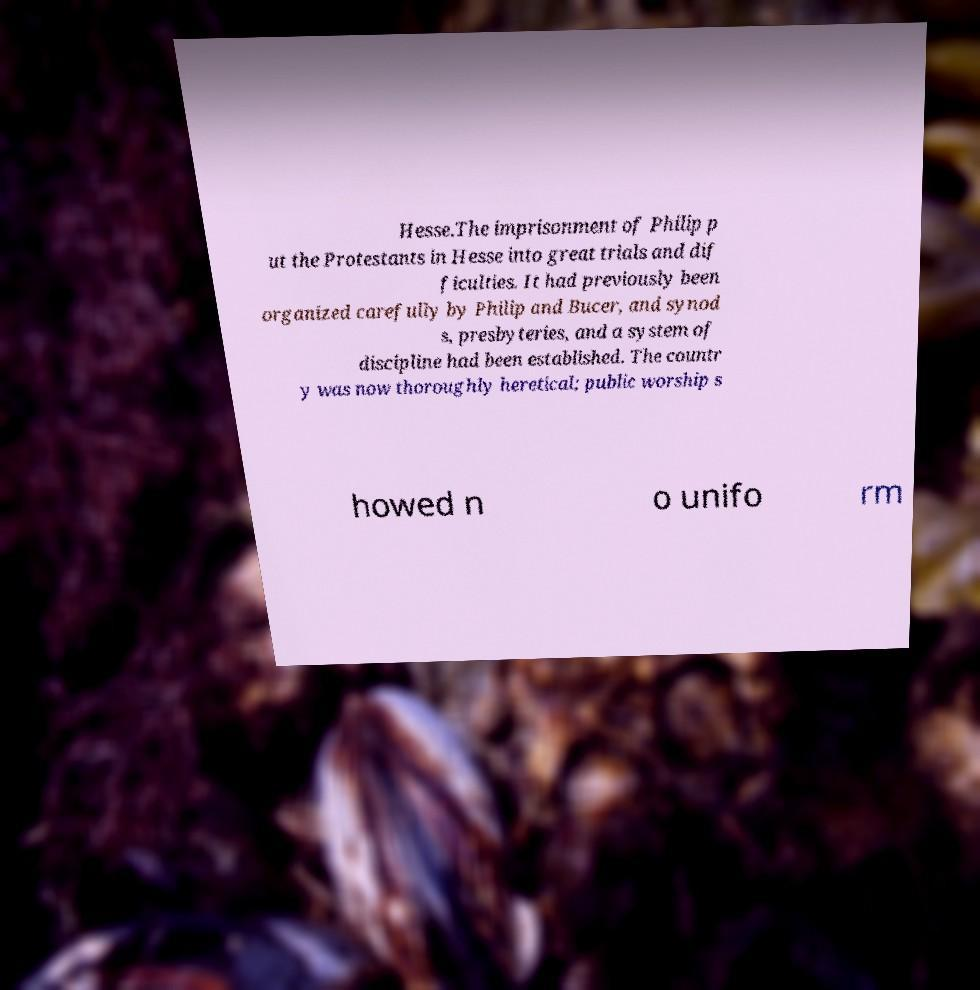There's text embedded in this image that I need extracted. Can you transcribe it verbatim? Hesse.The imprisonment of Philip p ut the Protestants in Hesse into great trials and dif ficulties. It had previously been organized carefully by Philip and Bucer, and synod s, presbyteries, and a system of discipline had been established. The countr y was now thoroughly heretical; public worship s howed n o unifo rm 